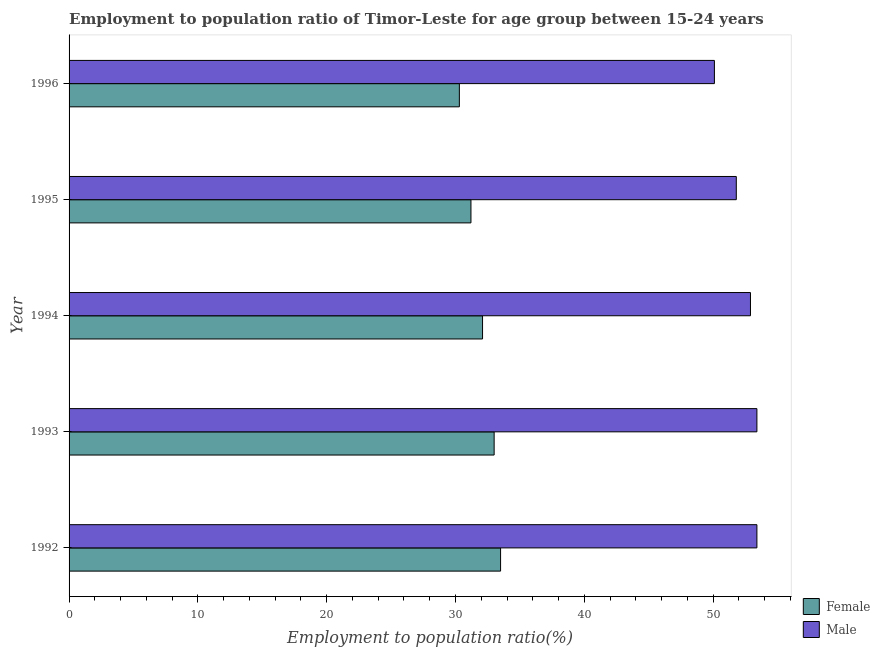Are the number of bars per tick equal to the number of legend labels?
Your answer should be very brief. Yes. Are the number of bars on each tick of the Y-axis equal?
Your answer should be compact. Yes. How many bars are there on the 1st tick from the top?
Your response must be concise. 2. How many bars are there on the 5th tick from the bottom?
Keep it short and to the point. 2. What is the label of the 5th group of bars from the top?
Offer a very short reply. 1992. What is the employment to population ratio(female) in 1996?
Offer a terse response. 30.3. Across all years, what is the maximum employment to population ratio(female)?
Provide a succinct answer. 33.5. Across all years, what is the minimum employment to population ratio(female)?
Give a very brief answer. 30.3. What is the total employment to population ratio(female) in the graph?
Ensure brevity in your answer.  160.1. What is the difference between the employment to population ratio(male) in 1994 and the employment to population ratio(female) in 1992?
Your answer should be very brief. 19.4. What is the average employment to population ratio(male) per year?
Your answer should be compact. 52.32. In the year 1992, what is the difference between the employment to population ratio(male) and employment to population ratio(female)?
Offer a terse response. 19.9. In how many years, is the employment to population ratio(male) greater than 52 %?
Offer a very short reply. 3. What is the difference between the highest and the lowest employment to population ratio(female)?
Ensure brevity in your answer.  3.2. How many bars are there?
Offer a terse response. 10. Are all the bars in the graph horizontal?
Your answer should be compact. Yes. How many years are there in the graph?
Provide a succinct answer. 5. What is the difference between two consecutive major ticks on the X-axis?
Your answer should be compact. 10. Does the graph contain any zero values?
Provide a succinct answer. No. Where does the legend appear in the graph?
Your answer should be very brief. Bottom right. How many legend labels are there?
Ensure brevity in your answer.  2. What is the title of the graph?
Your response must be concise. Employment to population ratio of Timor-Leste for age group between 15-24 years. What is the label or title of the Y-axis?
Make the answer very short. Year. What is the Employment to population ratio(%) of Female in 1992?
Provide a succinct answer. 33.5. What is the Employment to population ratio(%) of Male in 1992?
Make the answer very short. 53.4. What is the Employment to population ratio(%) in Male in 1993?
Ensure brevity in your answer.  53.4. What is the Employment to population ratio(%) in Female in 1994?
Offer a very short reply. 32.1. What is the Employment to population ratio(%) of Male in 1994?
Ensure brevity in your answer.  52.9. What is the Employment to population ratio(%) in Female in 1995?
Provide a short and direct response. 31.2. What is the Employment to population ratio(%) in Male in 1995?
Provide a short and direct response. 51.8. What is the Employment to population ratio(%) of Female in 1996?
Your response must be concise. 30.3. What is the Employment to population ratio(%) of Male in 1996?
Keep it short and to the point. 50.1. Across all years, what is the maximum Employment to population ratio(%) of Female?
Ensure brevity in your answer.  33.5. Across all years, what is the maximum Employment to population ratio(%) in Male?
Provide a short and direct response. 53.4. Across all years, what is the minimum Employment to population ratio(%) in Female?
Your response must be concise. 30.3. Across all years, what is the minimum Employment to population ratio(%) in Male?
Your answer should be compact. 50.1. What is the total Employment to population ratio(%) in Female in the graph?
Keep it short and to the point. 160.1. What is the total Employment to population ratio(%) of Male in the graph?
Give a very brief answer. 261.6. What is the difference between the Employment to population ratio(%) in Female in 1992 and that in 1993?
Provide a succinct answer. 0.5. What is the difference between the Employment to population ratio(%) in Male in 1992 and that in 1993?
Ensure brevity in your answer.  0. What is the difference between the Employment to population ratio(%) in Male in 1992 and that in 1994?
Provide a short and direct response. 0.5. What is the difference between the Employment to population ratio(%) of Female in 1992 and that in 1995?
Your response must be concise. 2.3. What is the difference between the Employment to population ratio(%) of Female in 1993 and that in 1994?
Provide a succinct answer. 0.9. What is the difference between the Employment to population ratio(%) in Male in 1993 and that in 1996?
Give a very brief answer. 3.3. What is the difference between the Employment to population ratio(%) of Female in 1994 and that in 1995?
Keep it short and to the point. 0.9. What is the difference between the Employment to population ratio(%) of Male in 1994 and that in 1995?
Your answer should be compact. 1.1. What is the difference between the Employment to population ratio(%) of Female in 1994 and that in 1996?
Your answer should be compact. 1.8. What is the difference between the Employment to population ratio(%) in Female in 1992 and the Employment to population ratio(%) in Male in 1993?
Provide a short and direct response. -19.9. What is the difference between the Employment to population ratio(%) of Female in 1992 and the Employment to population ratio(%) of Male in 1994?
Ensure brevity in your answer.  -19.4. What is the difference between the Employment to population ratio(%) of Female in 1992 and the Employment to population ratio(%) of Male in 1995?
Your response must be concise. -18.3. What is the difference between the Employment to population ratio(%) in Female in 1992 and the Employment to population ratio(%) in Male in 1996?
Offer a very short reply. -16.6. What is the difference between the Employment to population ratio(%) in Female in 1993 and the Employment to population ratio(%) in Male in 1994?
Offer a very short reply. -19.9. What is the difference between the Employment to population ratio(%) in Female in 1993 and the Employment to population ratio(%) in Male in 1995?
Ensure brevity in your answer.  -18.8. What is the difference between the Employment to population ratio(%) of Female in 1993 and the Employment to population ratio(%) of Male in 1996?
Your response must be concise. -17.1. What is the difference between the Employment to population ratio(%) in Female in 1994 and the Employment to population ratio(%) in Male in 1995?
Your response must be concise. -19.7. What is the difference between the Employment to population ratio(%) in Female in 1994 and the Employment to population ratio(%) in Male in 1996?
Provide a short and direct response. -18. What is the difference between the Employment to population ratio(%) of Female in 1995 and the Employment to population ratio(%) of Male in 1996?
Ensure brevity in your answer.  -18.9. What is the average Employment to population ratio(%) of Female per year?
Make the answer very short. 32.02. What is the average Employment to population ratio(%) of Male per year?
Ensure brevity in your answer.  52.32. In the year 1992, what is the difference between the Employment to population ratio(%) of Female and Employment to population ratio(%) of Male?
Give a very brief answer. -19.9. In the year 1993, what is the difference between the Employment to population ratio(%) in Female and Employment to population ratio(%) in Male?
Give a very brief answer. -20.4. In the year 1994, what is the difference between the Employment to population ratio(%) in Female and Employment to population ratio(%) in Male?
Provide a short and direct response. -20.8. In the year 1995, what is the difference between the Employment to population ratio(%) in Female and Employment to population ratio(%) in Male?
Keep it short and to the point. -20.6. In the year 1996, what is the difference between the Employment to population ratio(%) of Female and Employment to population ratio(%) of Male?
Your response must be concise. -19.8. What is the ratio of the Employment to population ratio(%) of Female in 1992 to that in 1993?
Your answer should be compact. 1.02. What is the ratio of the Employment to population ratio(%) in Male in 1992 to that in 1993?
Provide a short and direct response. 1. What is the ratio of the Employment to population ratio(%) of Female in 1992 to that in 1994?
Offer a very short reply. 1.04. What is the ratio of the Employment to population ratio(%) of Male in 1992 to that in 1994?
Provide a short and direct response. 1.01. What is the ratio of the Employment to population ratio(%) of Female in 1992 to that in 1995?
Offer a very short reply. 1.07. What is the ratio of the Employment to population ratio(%) of Male in 1992 to that in 1995?
Offer a terse response. 1.03. What is the ratio of the Employment to population ratio(%) in Female in 1992 to that in 1996?
Make the answer very short. 1.11. What is the ratio of the Employment to population ratio(%) in Male in 1992 to that in 1996?
Give a very brief answer. 1.07. What is the ratio of the Employment to population ratio(%) in Female in 1993 to that in 1994?
Make the answer very short. 1.03. What is the ratio of the Employment to population ratio(%) of Male in 1993 to that in 1994?
Provide a short and direct response. 1.01. What is the ratio of the Employment to population ratio(%) in Female in 1993 to that in 1995?
Give a very brief answer. 1.06. What is the ratio of the Employment to population ratio(%) in Male in 1993 to that in 1995?
Offer a terse response. 1.03. What is the ratio of the Employment to population ratio(%) of Female in 1993 to that in 1996?
Offer a terse response. 1.09. What is the ratio of the Employment to population ratio(%) of Male in 1993 to that in 1996?
Provide a short and direct response. 1.07. What is the ratio of the Employment to population ratio(%) in Female in 1994 to that in 1995?
Ensure brevity in your answer.  1.03. What is the ratio of the Employment to population ratio(%) of Male in 1994 to that in 1995?
Your answer should be very brief. 1.02. What is the ratio of the Employment to population ratio(%) in Female in 1994 to that in 1996?
Keep it short and to the point. 1.06. What is the ratio of the Employment to population ratio(%) in Male in 1994 to that in 1996?
Provide a short and direct response. 1.06. What is the ratio of the Employment to population ratio(%) in Female in 1995 to that in 1996?
Offer a very short reply. 1.03. What is the ratio of the Employment to population ratio(%) in Male in 1995 to that in 1996?
Keep it short and to the point. 1.03. What is the difference between the highest and the lowest Employment to population ratio(%) of Male?
Give a very brief answer. 3.3. 